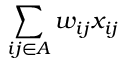Convert formula to latex. <formula><loc_0><loc_0><loc_500><loc_500>\sum _ { i j \in A } w _ { i j } x _ { i j }</formula> 